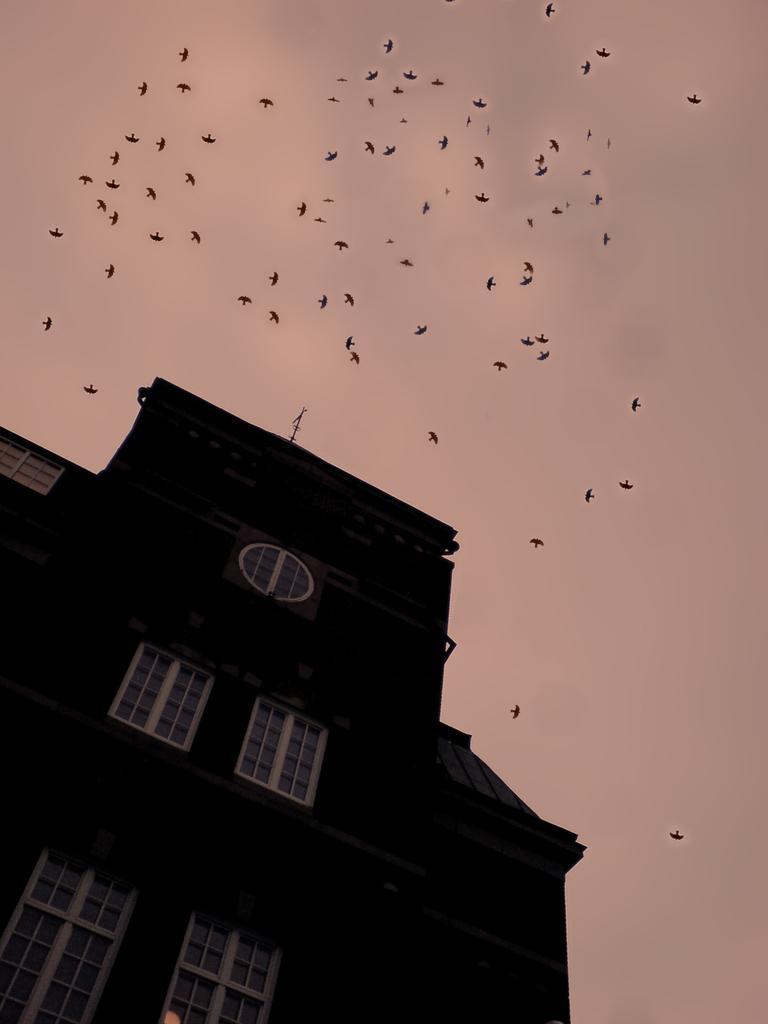Could you give a brief overview of what you see in this image? In the picture we can see a building which is black in color with windows and on the top of it, we can see a sky with many birds are flying. 